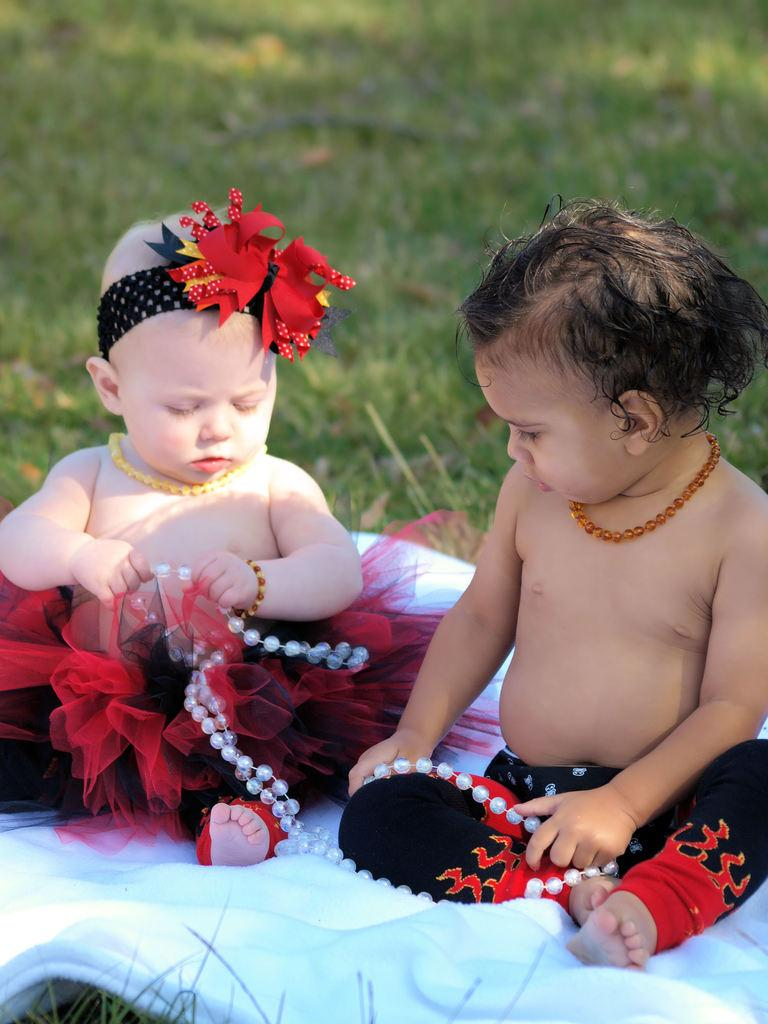How many children are in the image? A: There are two children in the image. What are the children doing in the image? The children are sitting on a blanket and holding a chain of pearls. What can be seen in the background of the image? There is grass visible in the background of the image. What type of authority does the creator of the pearls have in the image? There is no mention of a creator in the image, and the pearls are not depicted as having any authority. 